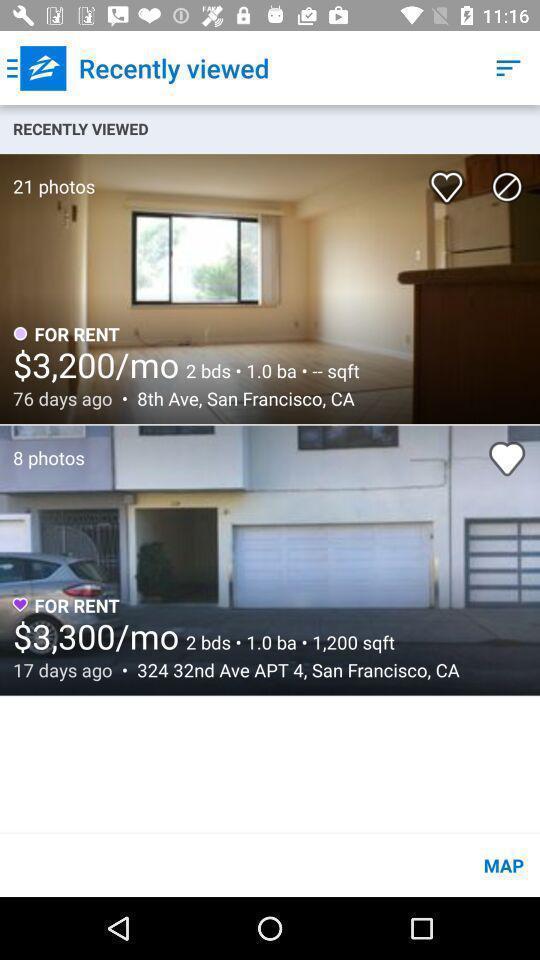Give me a narrative description of this picture. Page displaying recently viewed locations. 